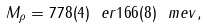<formula> <loc_0><loc_0><loc_500><loc_500>M _ { \rho } = 7 7 8 ( 4 ) \ e r { 1 6 } { 6 } ( 8 ) \ m e v , \\</formula> 